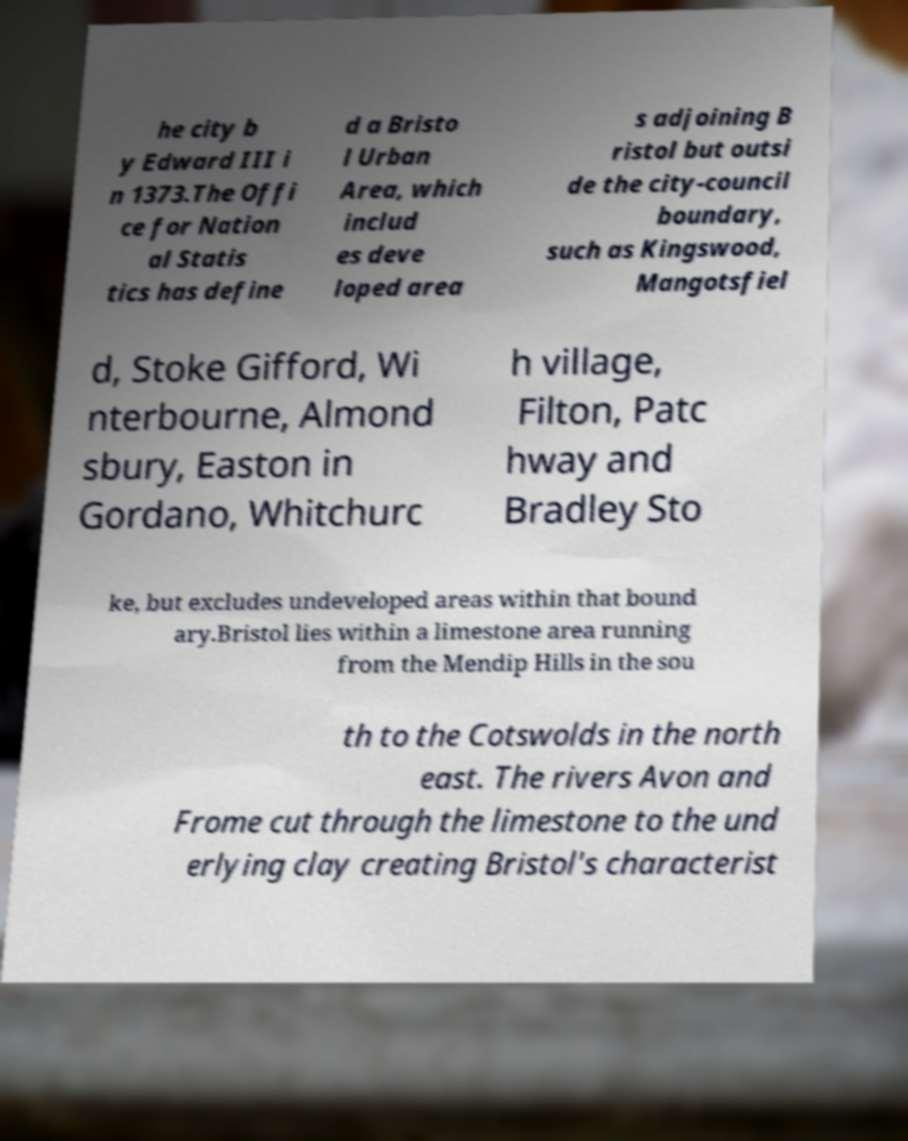What messages or text are displayed in this image? I need them in a readable, typed format. he city b y Edward III i n 1373.The Offi ce for Nation al Statis tics has define d a Bristo l Urban Area, which includ es deve loped area s adjoining B ristol but outsi de the city-council boundary, such as Kingswood, Mangotsfiel d, Stoke Gifford, Wi nterbourne, Almond sbury, Easton in Gordano, Whitchurc h village, Filton, Patc hway and Bradley Sto ke, but excludes undeveloped areas within that bound ary.Bristol lies within a limestone area running from the Mendip Hills in the sou th to the Cotswolds in the north east. The rivers Avon and Frome cut through the limestone to the und erlying clay creating Bristol's characterist 